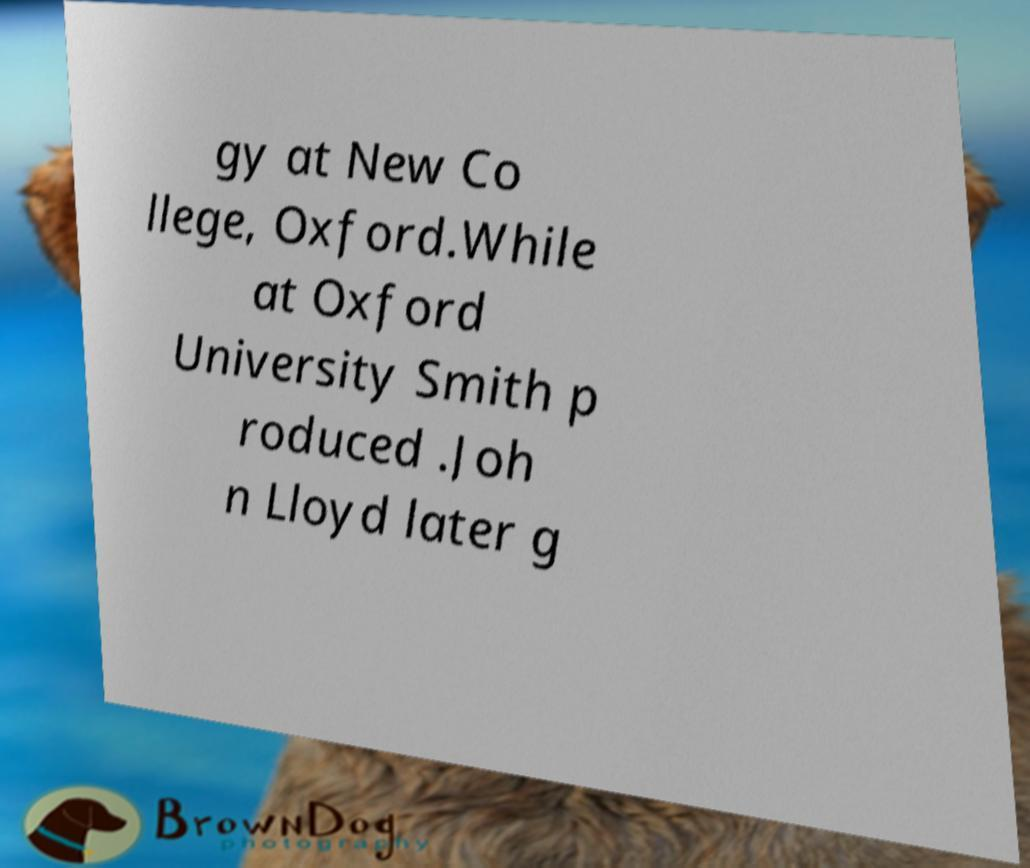Could you extract and type out the text from this image? gy at New Co llege, Oxford.While at Oxford University Smith p roduced .Joh n Lloyd later g 